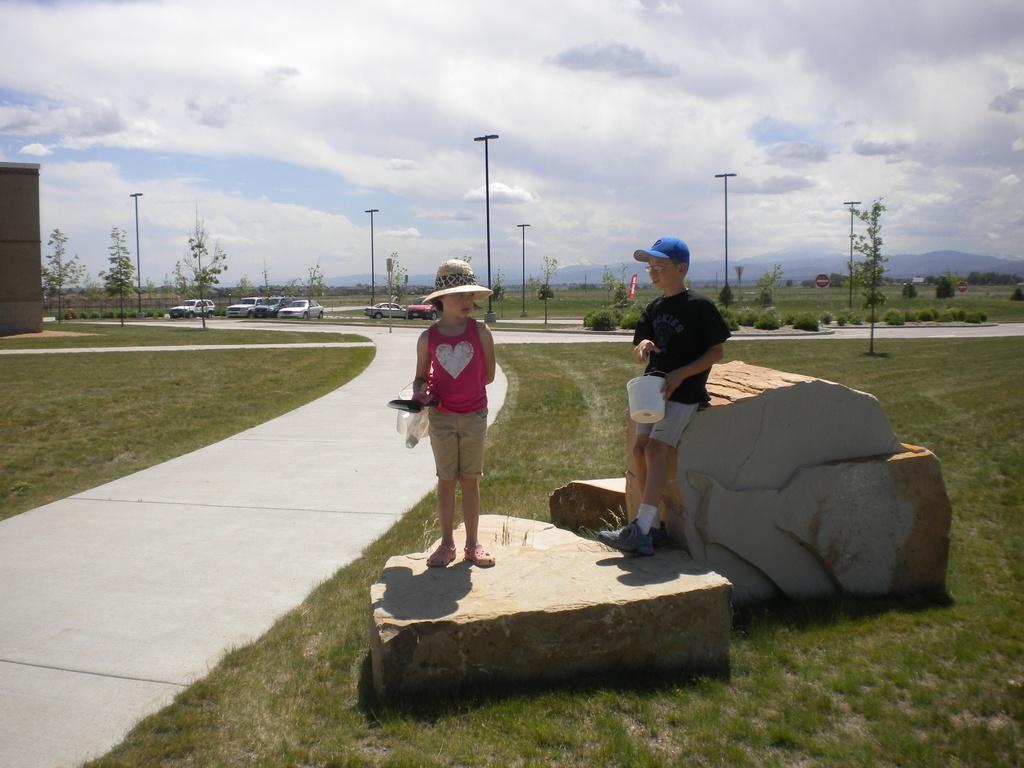Could you give a brief overview of what you see in this image? In this picture we can see two children standing on a rock, grass, path, plants, poles, vehicles, trees, some objects and in the background we can see the sky with clouds. 